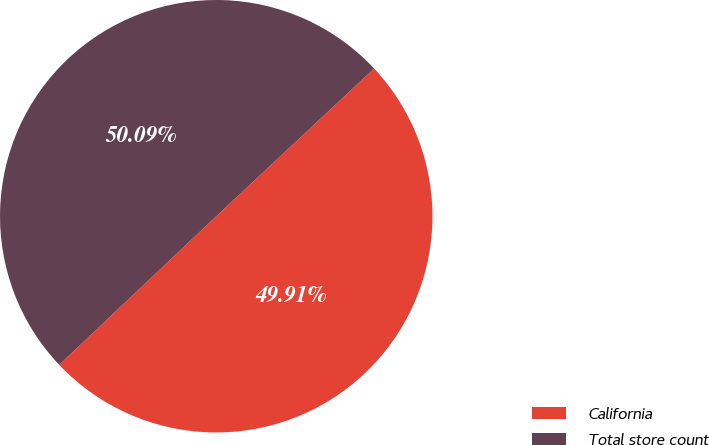Convert chart. <chart><loc_0><loc_0><loc_500><loc_500><pie_chart><fcel>California<fcel>Total store count<nl><fcel>49.91%<fcel>50.09%<nl></chart> 